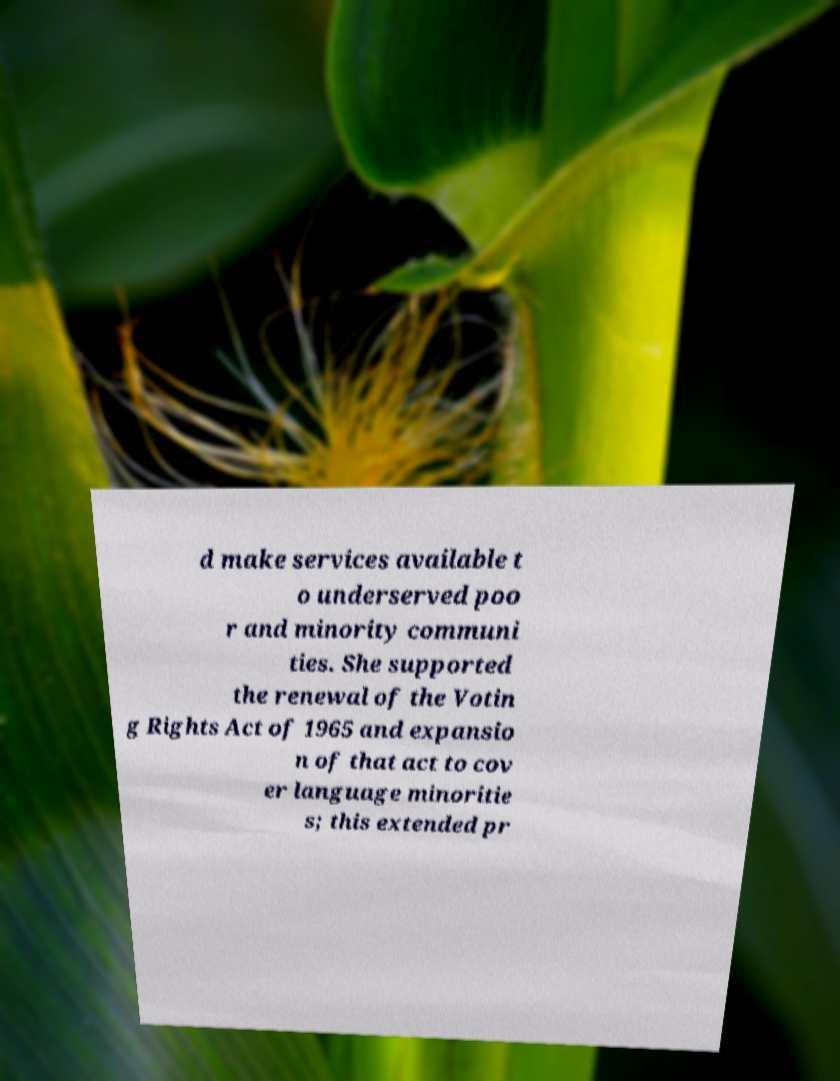Can you read and provide the text displayed in the image?This photo seems to have some interesting text. Can you extract and type it out for me? d make services available t o underserved poo r and minority communi ties. She supported the renewal of the Votin g Rights Act of 1965 and expansio n of that act to cov er language minoritie s; this extended pr 